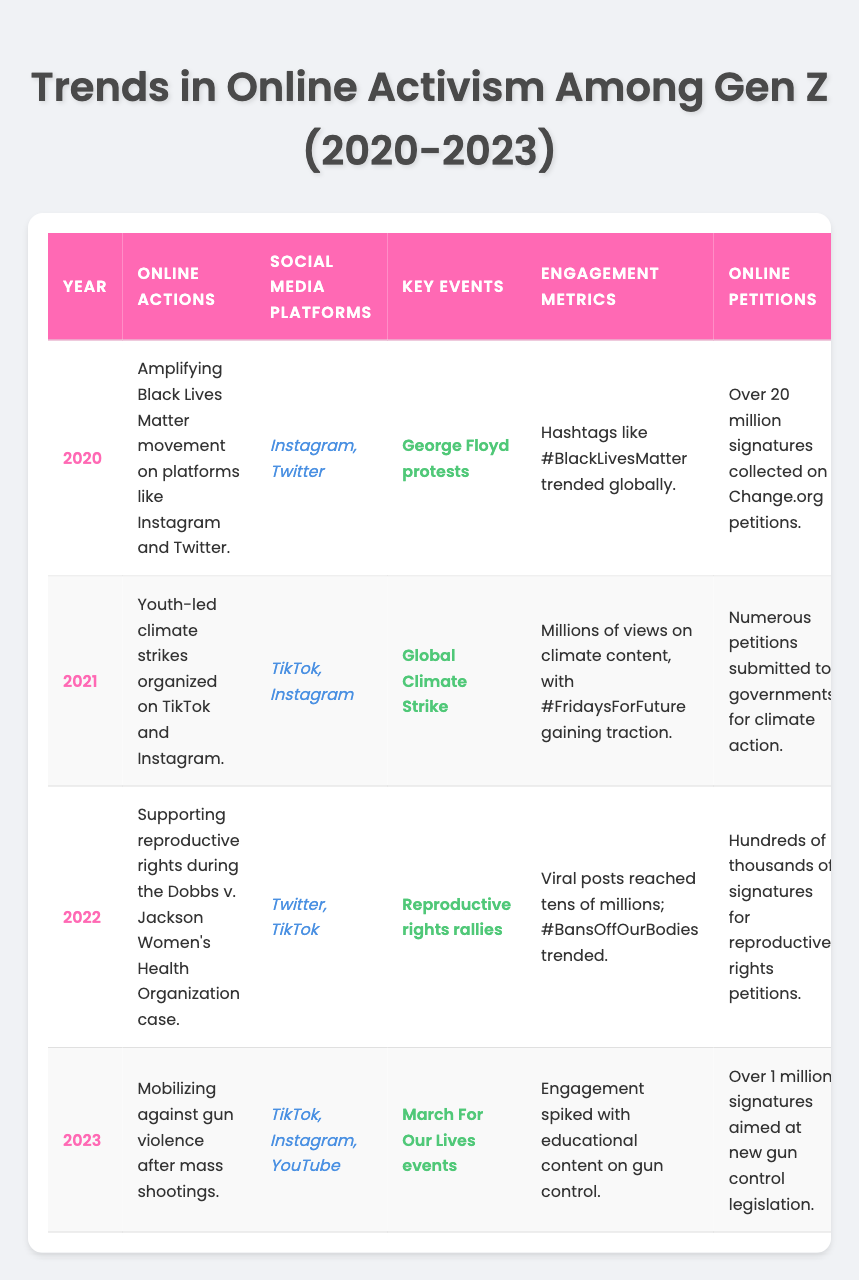What online actions did Gen Z engage in during 2021? According to the table, in 2021, Gen Z engaged in youth-led climate strikes organized on TikTok and Instagram.
Answer: Youth-led climate strikes on TikTok and Instagram Which social media platform was used most frequently across the years listed? By examining the table, both Instagram and TikTok appear multiple times, but Instagram was specifically mentioned in 2020 and 2021, while TikTok appeared in 2021, 2022, and 2023. Since Instagram appeared in more unique years, it is most frequently used.
Answer: Instagram How many signatures did online petitions receive in 2023? The table indicates that in 2023, over 1 million signatures were aimed at new gun control legislation through online petitions.
Answer: Over 1 million signatures True or false: The #FridaysForFuture hashtag gained traction in 2021. The table states that the hashtag #FridaysForFuture was associated with the youth-led climate strikes in 2021, confirming that it gained traction that year.
Answer: True What was the overall trend in online activism engagement metrics from 2020 to 2023? The engagement metrics show a progressive increase in activity: in 2020, hashtags trended globally, in 2021, millions of views were recorded, in 2022, posts reached tens of millions, and in 2023, engagement spiked with educational content on gun control. This shows a useful rise in online activism activities.
Answer: Increasing trend in engagement metrics In which year did the impact of online activism lead to increased mobilization and awareness across campuses? The table shows that in 2022, the impact of supporting reproductive rights during the Dobbs case led to increased mobilization and awareness across campuses.
Answer: 2022 What were the key events associated with online activism in 2020 and 2023? The key event for 2020 was the George Floyd protests, while for 2023, it was the March For Our Lives events.
Answer: George Floyd protests (2020) and March For Our Lives events (2023) How did the impact of online activism change from 2020 to 2023? The impact progressed from increased awareness of racial injustice in 2020, to pressure on policymakers for climate action in 2021, mobilization for reproductive rights in 2022, and strengthening of movements for stricter gun laws in 2023, indicating a more focused approach to each cause over the years.
Answer: More focused impact on specific causes How many signatures were collected for Change.org petitions in 2020 compared to 2021? In 2020, over 20 million signatures were collected on Change.org petitions, while the table does not provide a specific number for 2021, only stating numerous petitions were submitted, thus making direct comparison impossible.
Answer: Over 20 million (2020); no specific number for 2021 